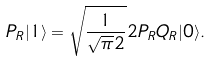<formula> <loc_0><loc_0><loc_500><loc_500>P _ { R } | 1 \rangle = \sqrt { \frac { 1 } { \sqrt { \pi } 2 } } 2 P _ { R } Q _ { R } | 0 \rangle .</formula> 